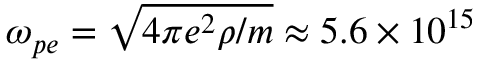Convert formula to latex. <formula><loc_0><loc_0><loc_500><loc_500>\omega _ { p e } = \sqrt { 4 \pi e ^ { 2 } \rho / m } \approx 5 . 6 \times 1 0 ^ { 1 5 }</formula> 